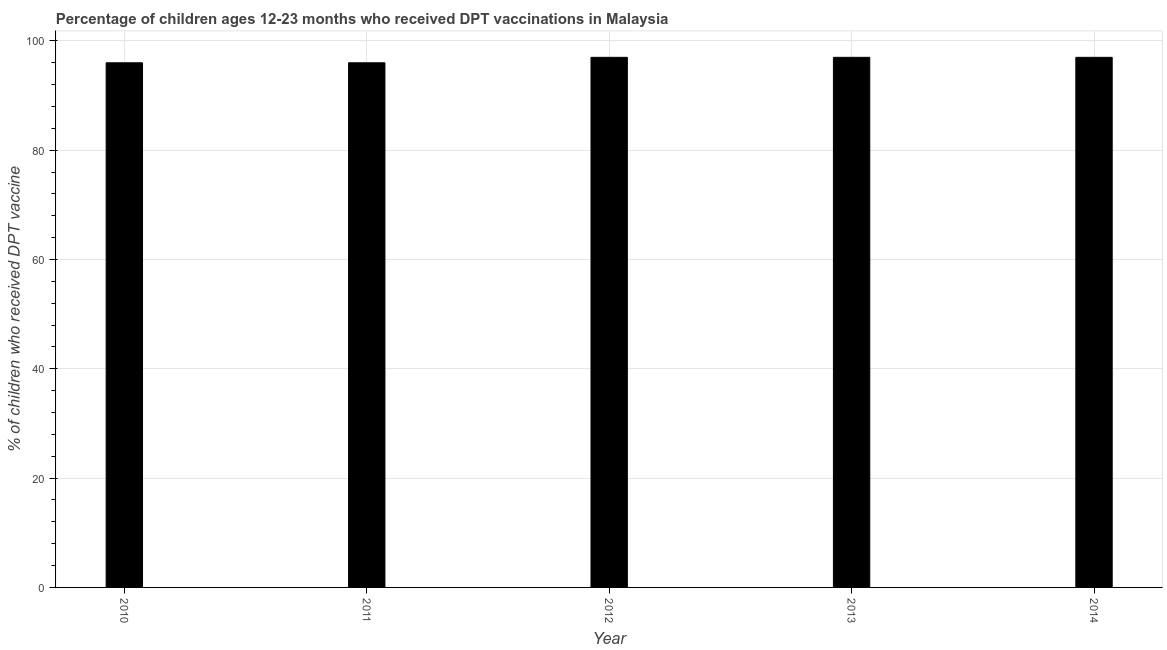Does the graph contain any zero values?
Provide a succinct answer. No. What is the title of the graph?
Make the answer very short. Percentage of children ages 12-23 months who received DPT vaccinations in Malaysia. What is the label or title of the X-axis?
Make the answer very short. Year. What is the label or title of the Y-axis?
Make the answer very short. % of children who received DPT vaccine. What is the percentage of children who received dpt vaccine in 2014?
Offer a very short reply. 97. Across all years, what is the maximum percentage of children who received dpt vaccine?
Keep it short and to the point. 97. Across all years, what is the minimum percentage of children who received dpt vaccine?
Give a very brief answer. 96. In which year was the percentage of children who received dpt vaccine minimum?
Ensure brevity in your answer.  2010. What is the sum of the percentage of children who received dpt vaccine?
Your answer should be compact. 483. What is the difference between the percentage of children who received dpt vaccine in 2012 and 2014?
Give a very brief answer. 0. What is the average percentage of children who received dpt vaccine per year?
Your answer should be compact. 96. What is the median percentage of children who received dpt vaccine?
Your response must be concise. 97. In how many years, is the percentage of children who received dpt vaccine greater than 32 %?
Ensure brevity in your answer.  5. Is the percentage of children who received dpt vaccine in 2013 less than that in 2014?
Ensure brevity in your answer.  No. Is the difference between the percentage of children who received dpt vaccine in 2011 and 2014 greater than the difference between any two years?
Your response must be concise. Yes. What is the difference between the highest and the second highest percentage of children who received dpt vaccine?
Ensure brevity in your answer.  0. Is the sum of the percentage of children who received dpt vaccine in 2011 and 2014 greater than the maximum percentage of children who received dpt vaccine across all years?
Make the answer very short. Yes. What is the difference between the highest and the lowest percentage of children who received dpt vaccine?
Your answer should be compact. 1. In how many years, is the percentage of children who received dpt vaccine greater than the average percentage of children who received dpt vaccine taken over all years?
Your answer should be compact. 3. Are all the bars in the graph horizontal?
Your response must be concise. No. How many years are there in the graph?
Provide a succinct answer. 5. Are the values on the major ticks of Y-axis written in scientific E-notation?
Make the answer very short. No. What is the % of children who received DPT vaccine of 2010?
Give a very brief answer. 96. What is the % of children who received DPT vaccine of 2011?
Provide a succinct answer. 96. What is the % of children who received DPT vaccine in 2012?
Your response must be concise. 97. What is the % of children who received DPT vaccine of 2013?
Provide a short and direct response. 97. What is the % of children who received DPT vaccine in 2014?
Make the answer very short. 97. What is the difference between the % of children who received DPT vaccine in 2010 and 2011?
Keep it short and to the point. 0. What is the difference between the % of children who received DPT vaccine in 2011 and 2013?
Ensure brevity in your answer.  -1. What is the difference between the % of children who received DPT vaccine in 2013 and 2014?
Provide a succinct answer. 0. What is the ratio of the % of children who received DPT vaccine in 2010 to that in 2011?
Offer a terse response. 1. What is the ratio of the % of children who received DPT vaccine in 2010 to that in 2012?
Offer a terse response. 0.99. What is the ratio of the % of children who received DPT vaccine in 2010 to that in 2013?
Provide a succinct answer. 0.99. What is the ratio of the % of children who received DPT vaccine in 2010 to that in 2014?
Offer a very short reply. 0.99. What is the ratio of the % of children who received DPT vaccine in 2011 to that in 2013?
Make the answer very short. 0.99. 